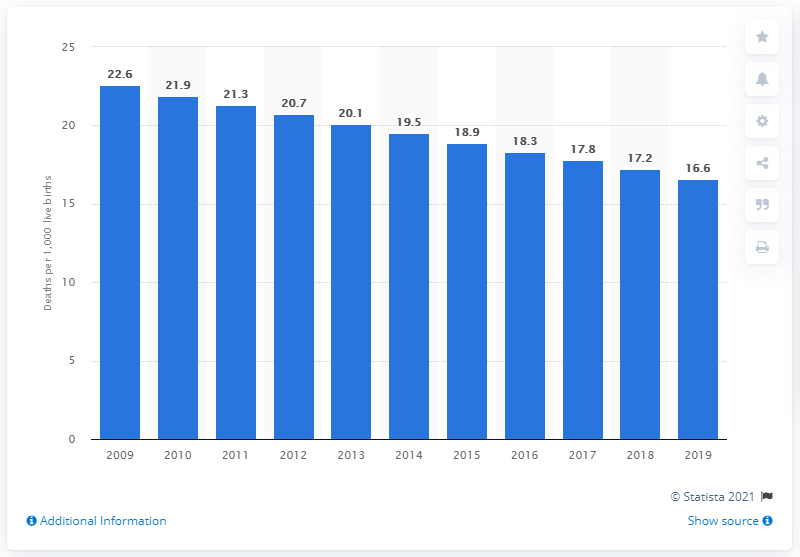Point out several critical features in this image. According to data from 2019, the infant mortality rate in Paraguay was 16.6 deaths per 1,000 live births. 